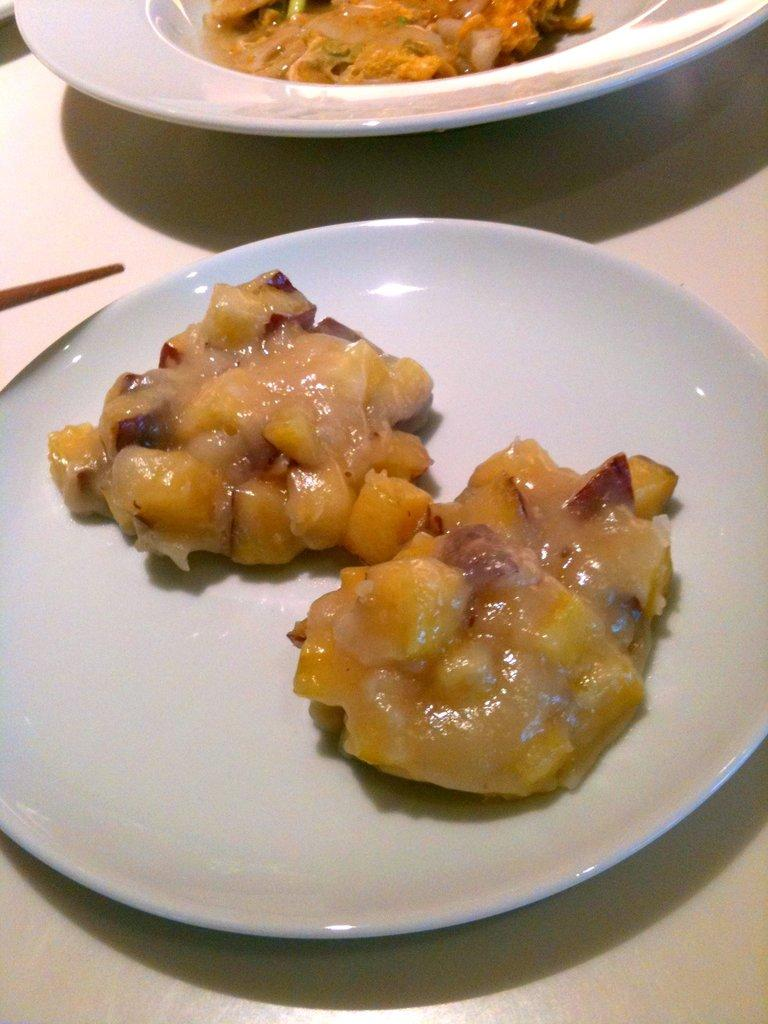What is on the plate that is visible in the image? There is food in a plate in the image. Where is the plate located in the image? The plate is placed on a table. How many icicles are hanging from the plate in the image? There are no icicles present in the image; it features a plate of food on a table. What type of eggs can be seen in the image? There are no eggs present in the image. 